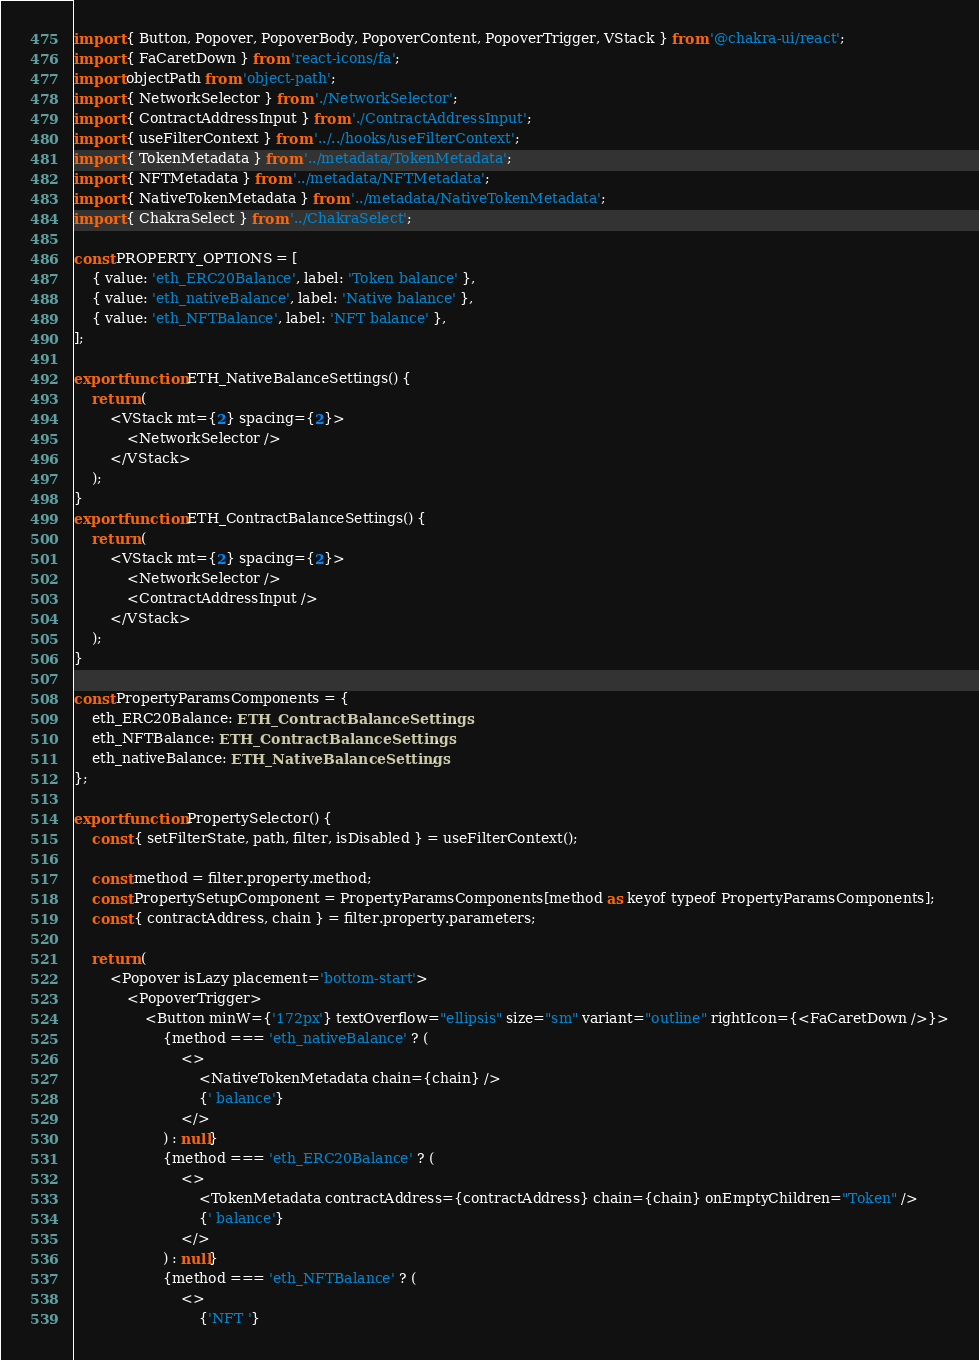Convert code to text. <code><loc_0><loc_0><loc_500><loc_500><_TypeScript_>import { Button, Popover, PopoverBody, PopoverContent, PopoverTrigger, VStack } from '@chakra-ui/react';
import { FaCaretDown } from 'react-icons/fa';
import objectPath from 'object-path';
import { NetworkSelector } from './NetworkSelector';
import { ContractAddressInput } from './ContractAddressInput';
import { useFilterContext } from '../../hooks/useFilterContext';
import { TokenMetadata } from '../metadata/TokenMetadata';
import { NFTMetadata } from '../metadata/NFTMetadata';
import { NativeTokenMetadata } from '../metadata/NativeTokenMetadata';
import { ChakraSelect } from '../ChakraSelect';

const PROPERTY_OPTIONS = [
	{ value: 'eth_ERC20Balance', label: 'Token balance' },
	{ value: 'eth_nativeBalance', label: 'Native balance' },
	{ value: 'eth_NFTBalance', label: 'NFT balance' },
];

export function ETH_NativeBalanceSettings() {
	return (
		<VStack mt={2} spacing={2}>
			<NetworkSelector />
		</VStack>
	);
}
export function ETH_ContractBalanceSettings() {
	return (
		<VStack mt={2} spacing={2}>
			<NetworkSelector />
			<ContractAddressInput />
		</VStack>
	);
}

const PropertyParamsComponents = {
	eth_ERC20Balance: ETH_ContractBalanceSettings,
	eth_NFTBalance: ETH_ContractBalanceSettings,
	eth_nativeBalance: ETH_NativeBalanceSettings,
};

export function PropertySelector() {
	const { setFilterState, path, filter, isDisabled } = useFilterContext();

	const method = filter.property.method;
	const PropertySetupComponent = PropertyParamsComponents[method as keyof typeof PropertyParamsComponents];
	const { contractAddress, chain } = filter.property.parameters;

	return (
		<Popover isLazy placement='bottom-start'>
			<PopoverTrigger>
				<Button minW={'172px'} textOverflow="ellipsis" size="sm" variant="outline" rightIcon={<FaCaretDown />}>
					{method === 'eth_nativeBalance' ? (
						<>
							<NativeTokenMetadata chain={chain} />
							{' balance'}
						</>
					) : null}
					{method === 'eth_ERC20Balance' ? (
						<>
							<TokenMetadata contractAddress={contractAddress} chain={chain} onEmptyChildren="Token" />
							{' balance'}
						</>
					) : null}
					{method === 'eth_NFTBalance' ? (
						<>
							{'NFT '}</code> 